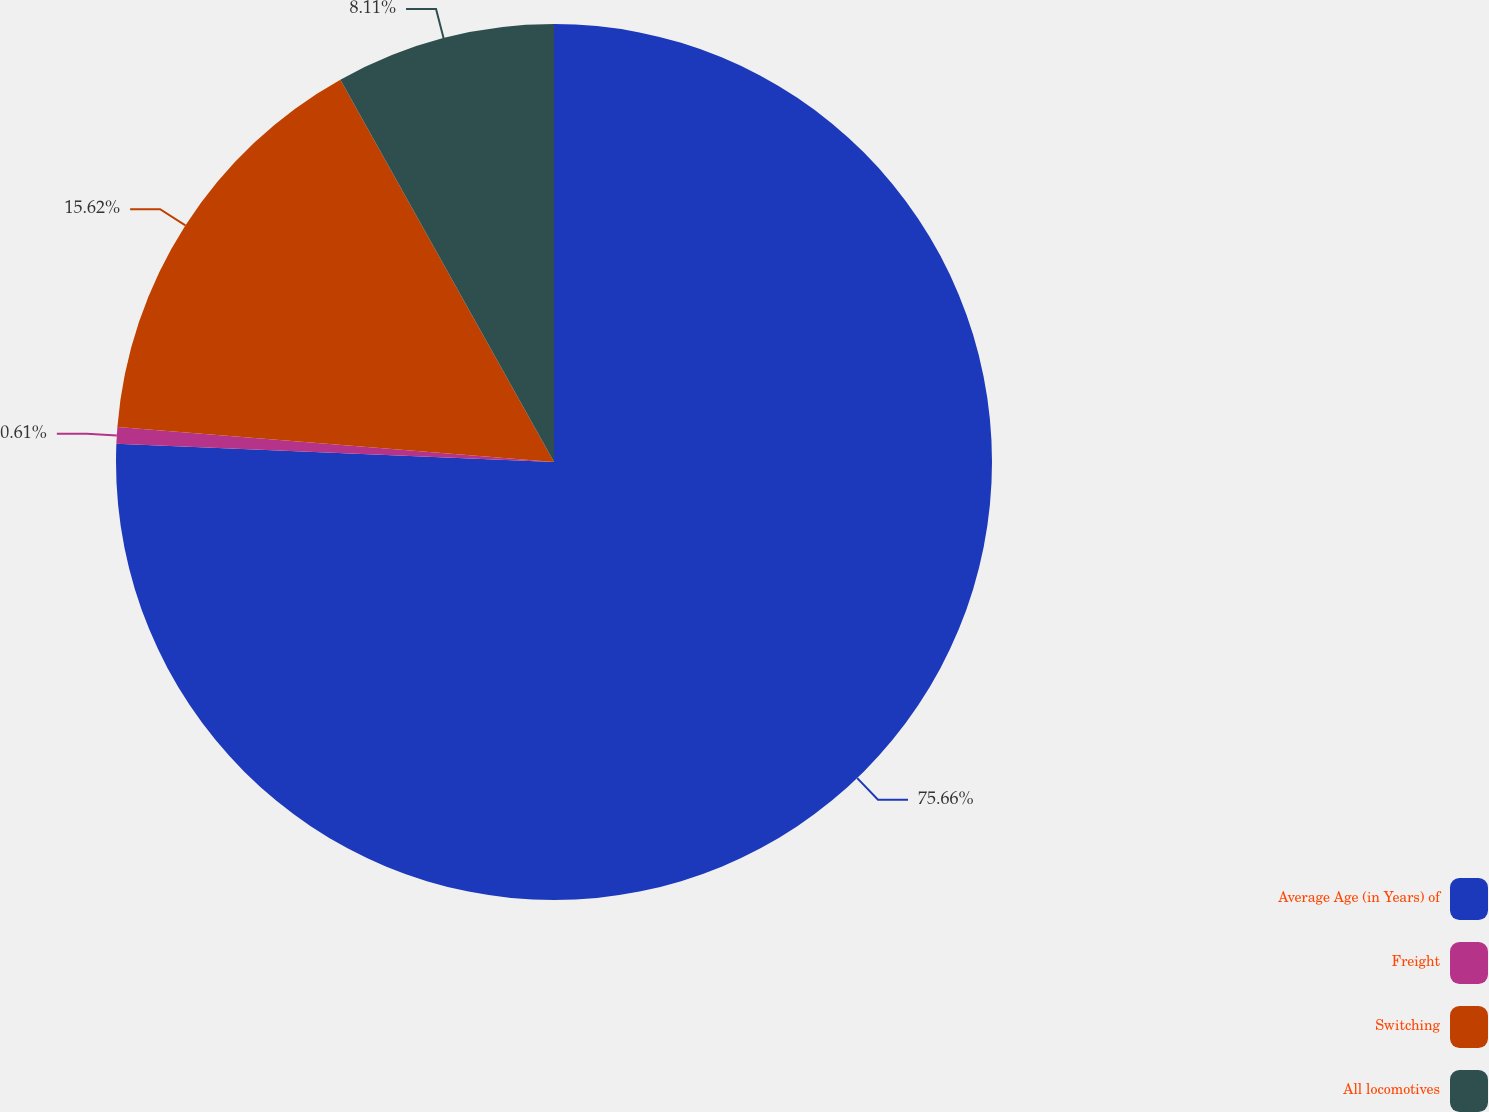Convert chart. <chart><loc_0><loc_0><loc_500><loc_500><pie_chart><fcel>Average Age (in Years) of<fcel>Freight<fcel>Switching<fcel>All locomotives<nl><fcel>75.66%<fcel>0.61%<fcel>15.62%<fcel>8.11%<nl></chart> 